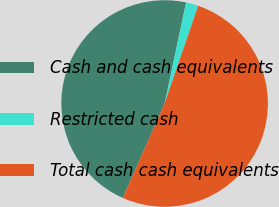Convert chart to OTSL. <chart><loc_0><loc_0><loc_500><loc_500><pie_chart><fcel>Cash and cash equivalents<fcel>Restricted cash<fcel>Total cash cash equivalents<nl><fcel>46.7%<fcel>1.93%<fcel>51.37%<nl></chart> 